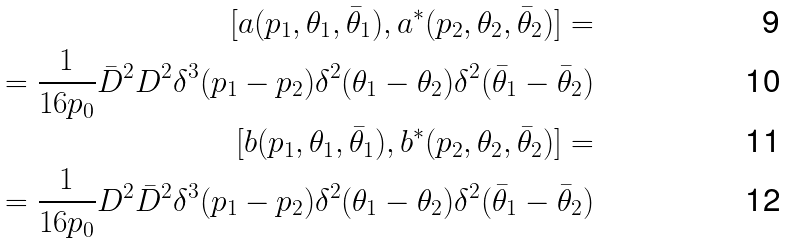Convert formula to latex. <formula><loc_0><loc_0><loc_500><loc_500>[ a ( p _ { 1 } , \theta _ { 1 } , \bar { \theta } _ { 1 } ) , a ^ { * } ( p _ { 2 } , \theta _ { 2 } , \bar { \theta } _ { 2 } ) ] = \\ = \frac { 1 } { 1 6 p _ { 0 } } \bar { D } ^ { 2 } D ^ { 2 } \delta ^ { 3 } ( p _ { 1 } - p _ { 2 } ) \delta ^ { 2 } ( \theta _ { 1 } - \theta _ { 2 } ) \delta ^ { 2 } ( \bar { \theta } _ { 1 } - \bar { \theta } _ { 2 } ) \\ [ b ( p _ { 1 } , \theta _ { 1 } , \bar { \theta } _ { 1 } ) , b ^ { * } ( p _ { 2 } , \theta _ { 2 } , \bar { \theta } _ { 2 } ) ] = \\ = \frac { 1 } { 1 6 p _ { 0 } } D ^ { 2 } \bar { D } ^ { 2 } \delta ^ { 3 } ( p _ { 1 } - p _ { 2 } ) \delta ^ { 2 } ( \theta _ { 1 } - \theta _ { 2 } ) \delta ^ { 2 } ( \bar { \theta } _ { 1 } - \bar { \theta } _ { 2 } )</formula> 